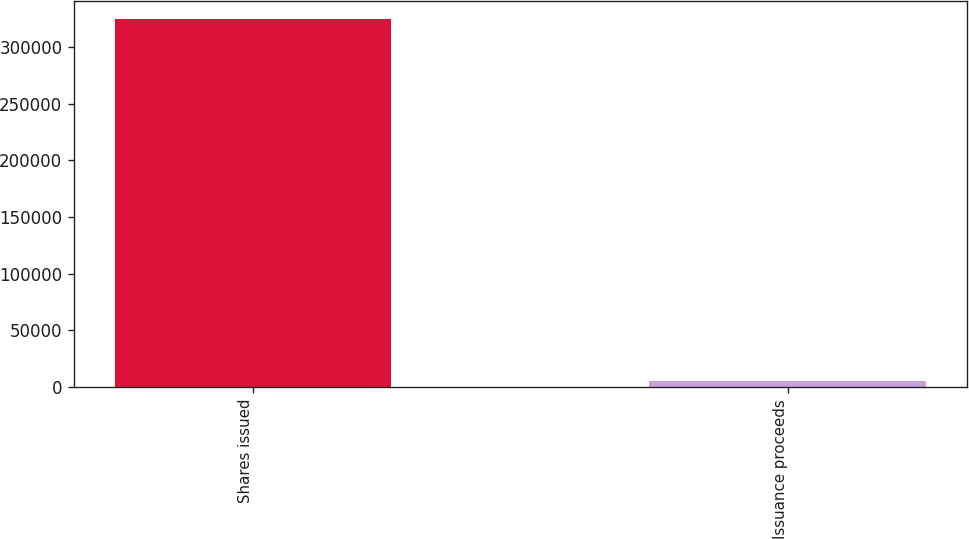Convert chart to OTSL. <chart><loc_0><loc_0><loc_500><loc_500><bar_chart><fcel>Shares issued<fcel>Issuance proceeds<nl><fcel>324394<fcel>5292<nl></chart> 